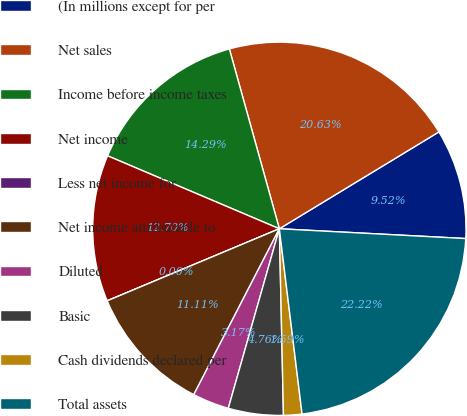Convert chart. <chart><loc_0><loc_0><loc_500><loc_500><pie_chart><fcel>(In millions except for per<fcel>Net sales<fcel>Income before income taxes<fcel>Net income<fcel>Less net income for<fcel>Net income attributable to<fcel>Diluted<fcel>Basic<fcel>Cash dividends declared per<fcel>Total assets<nl><fcel>9.52%<fcel>20.63%<fcel>14.29%<fcel>12.7%<fcel>0.0%<fcel>11.11%<fcel>3.17%<fcel>4.76%<fcel>1.59%<fcel>22.22%<nl></chart> 